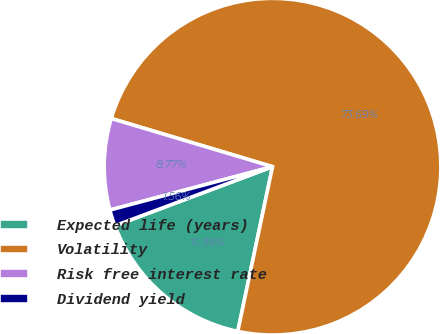Convert chart. <chart><loc_0><loc_0><loc_500><loc_500><pie_chart><fcel>Expected life (years)<fcel>Volatility<fcel>Risk free interest rate<fcel>Dividend yield<nl><fcel>15.98%<fcel>73.68%<fcel>8.77%<fcel>1.56%<nl></chart> 